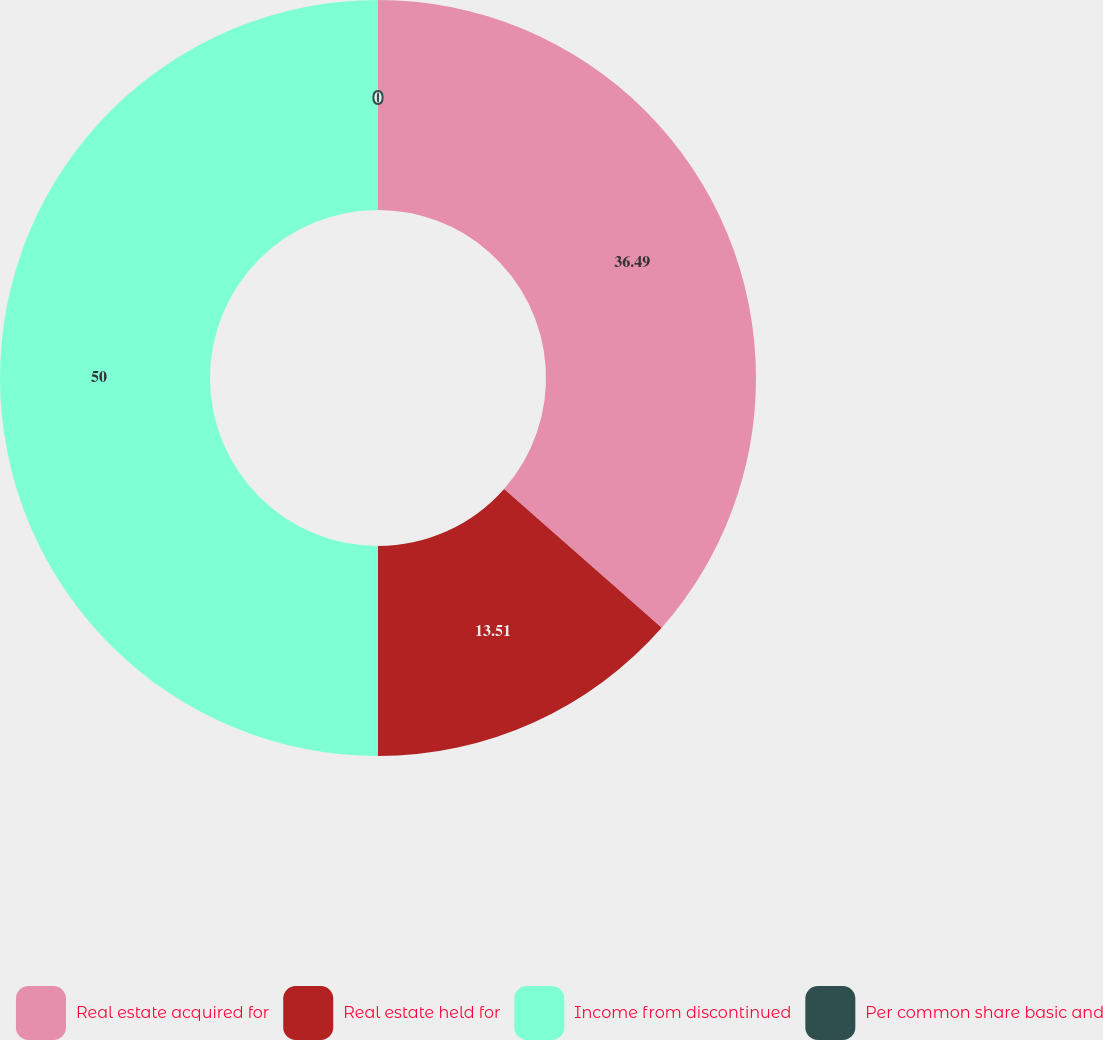Convert chart to OTSL. <chart><loc_0><loc_0><loc_500><loc_500><pie_chart><fcel>Real estate acquired for<fcel>Real estate held for<fcel>Income from discontinued<fcel>Per common share basic and<nl><fcel>36.49%<fcel>13.51%<fcel>50.0%<fcel>0.0%<nl></chart> 